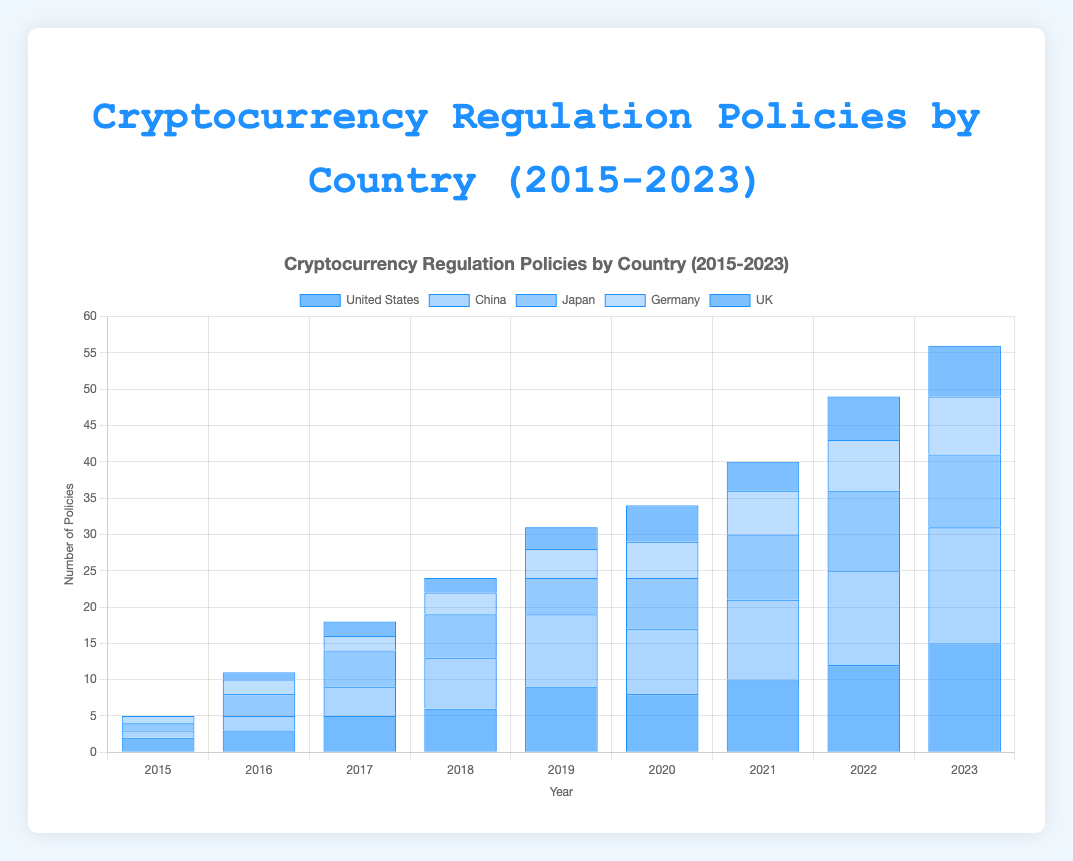Which country enacted the most cryptocurrency regulation policies in 2023? Looking at the year 2023 on the x-axis, the country with the tallest bar (indicating the largest number) is China.
Answer: China How did the number of policies in the United States change from 2015 to 2023? Calculate the difference in the number of policies between 2023 and 2015. The number of policies in 2015 is 2, and in 2023 it is 15. The difference is 15 - 2 = 13.
Answer: Increased by 13 Which year did Japan see the highest number of cryptocurrency regulation policies? By examining the bars for each year for Japan, the year with the tallest bar is 2022 with 11 policies.
Answer: 2022 What is the total number of cryptocurrency regulation policies enacted by Germany from 2015 to 2023? Sum the number of policies in Germany from 2015 to 2023: 1 + 2 + 2 + 3 + 4 + 5 + 6 + 7 + 8 = 38.
Answer: 38 Compare the number of policies enacted by the UK in 2018 and 2021. Which year had more? In 2018, the UK enacted 2 policies, and in 2021, it enacted 4 policies. Therefore, 2021 had more policies.
Answer: 2021 What is the average number of policies enacted by China in the years 2015, 2016, and 2017? Sum the number of policies in China for these years (1 + 2 + 4 = 7) and divide by the number of years (3). The average is 7 / 3 = 2.33.
Answer: 2.33 Which country showed the most consistent increase in the number of cryptocurrency regulation policies from 2015 to 2023? The visual pattern of a consistent increase (steady rise in bar heights year over year) is observed most clearly in China.
Answer: China Between 2020 and 2022, which country had the highest growth in cryptocurrency regulation policies? Calculate the difference in the number of policies between 2020 and 2022 for each country. The highest difference: China (13 - 9 = 4).
Answer: China 